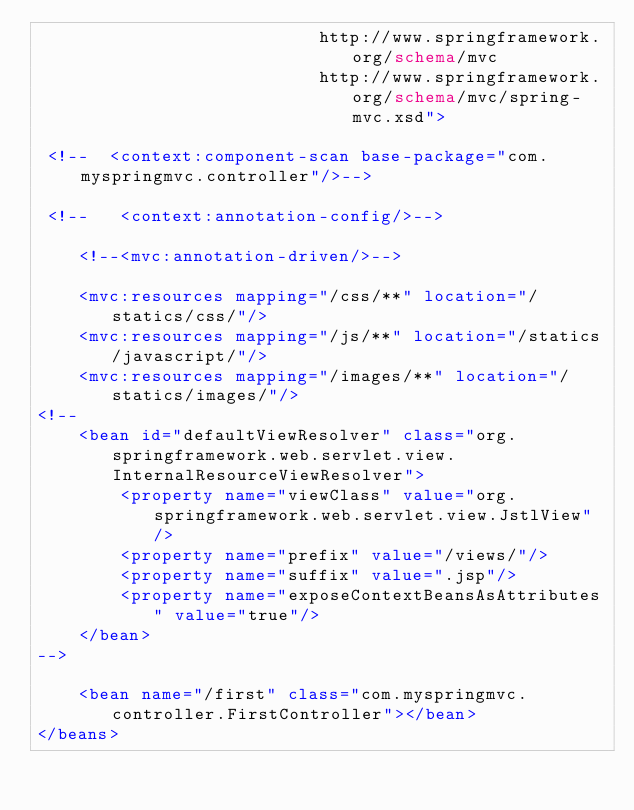Convert code to text. <code><loc_0><loc_0><loc_500><loc_500><_XML_>                           http://www.springframework.org/schema/mvc
                           http://www.springframework.org/schema/mvc/spring-mvc.xsd">

 <!--  <context:component-scan base-package="com.myspringmvc.controller"/>-->

 <!--   <context:annotation-config/>-->

    <!--<mvc:annotation-driven/>-->

    <mvc:resources mapping="/css/**" location="/statics/css/"/>
    <mvc:resources mapping="/js/**" location="/statics/javascript/"/>
    <mvc:resources mapping="/images/**" location="/statics/images/"/>
<!--
    <bean id="defaultViewResolver" class="org.springframework.web.servlet.view.InternalResourceViewResolver">
        <property name="viewClass" value="org.springframework.web.servlet.view.JstlView"/>
        <property name="prefix" value="/views/"/>
        <property name="suffix" value=".jsp"/>
        <property name="exposeContextBeansAsAttributes" value="true"/>
    </bean>
-->

    <bean name="/first" class="com.myspringmvc.controller.FirstController"></bean>
</beans></code> 